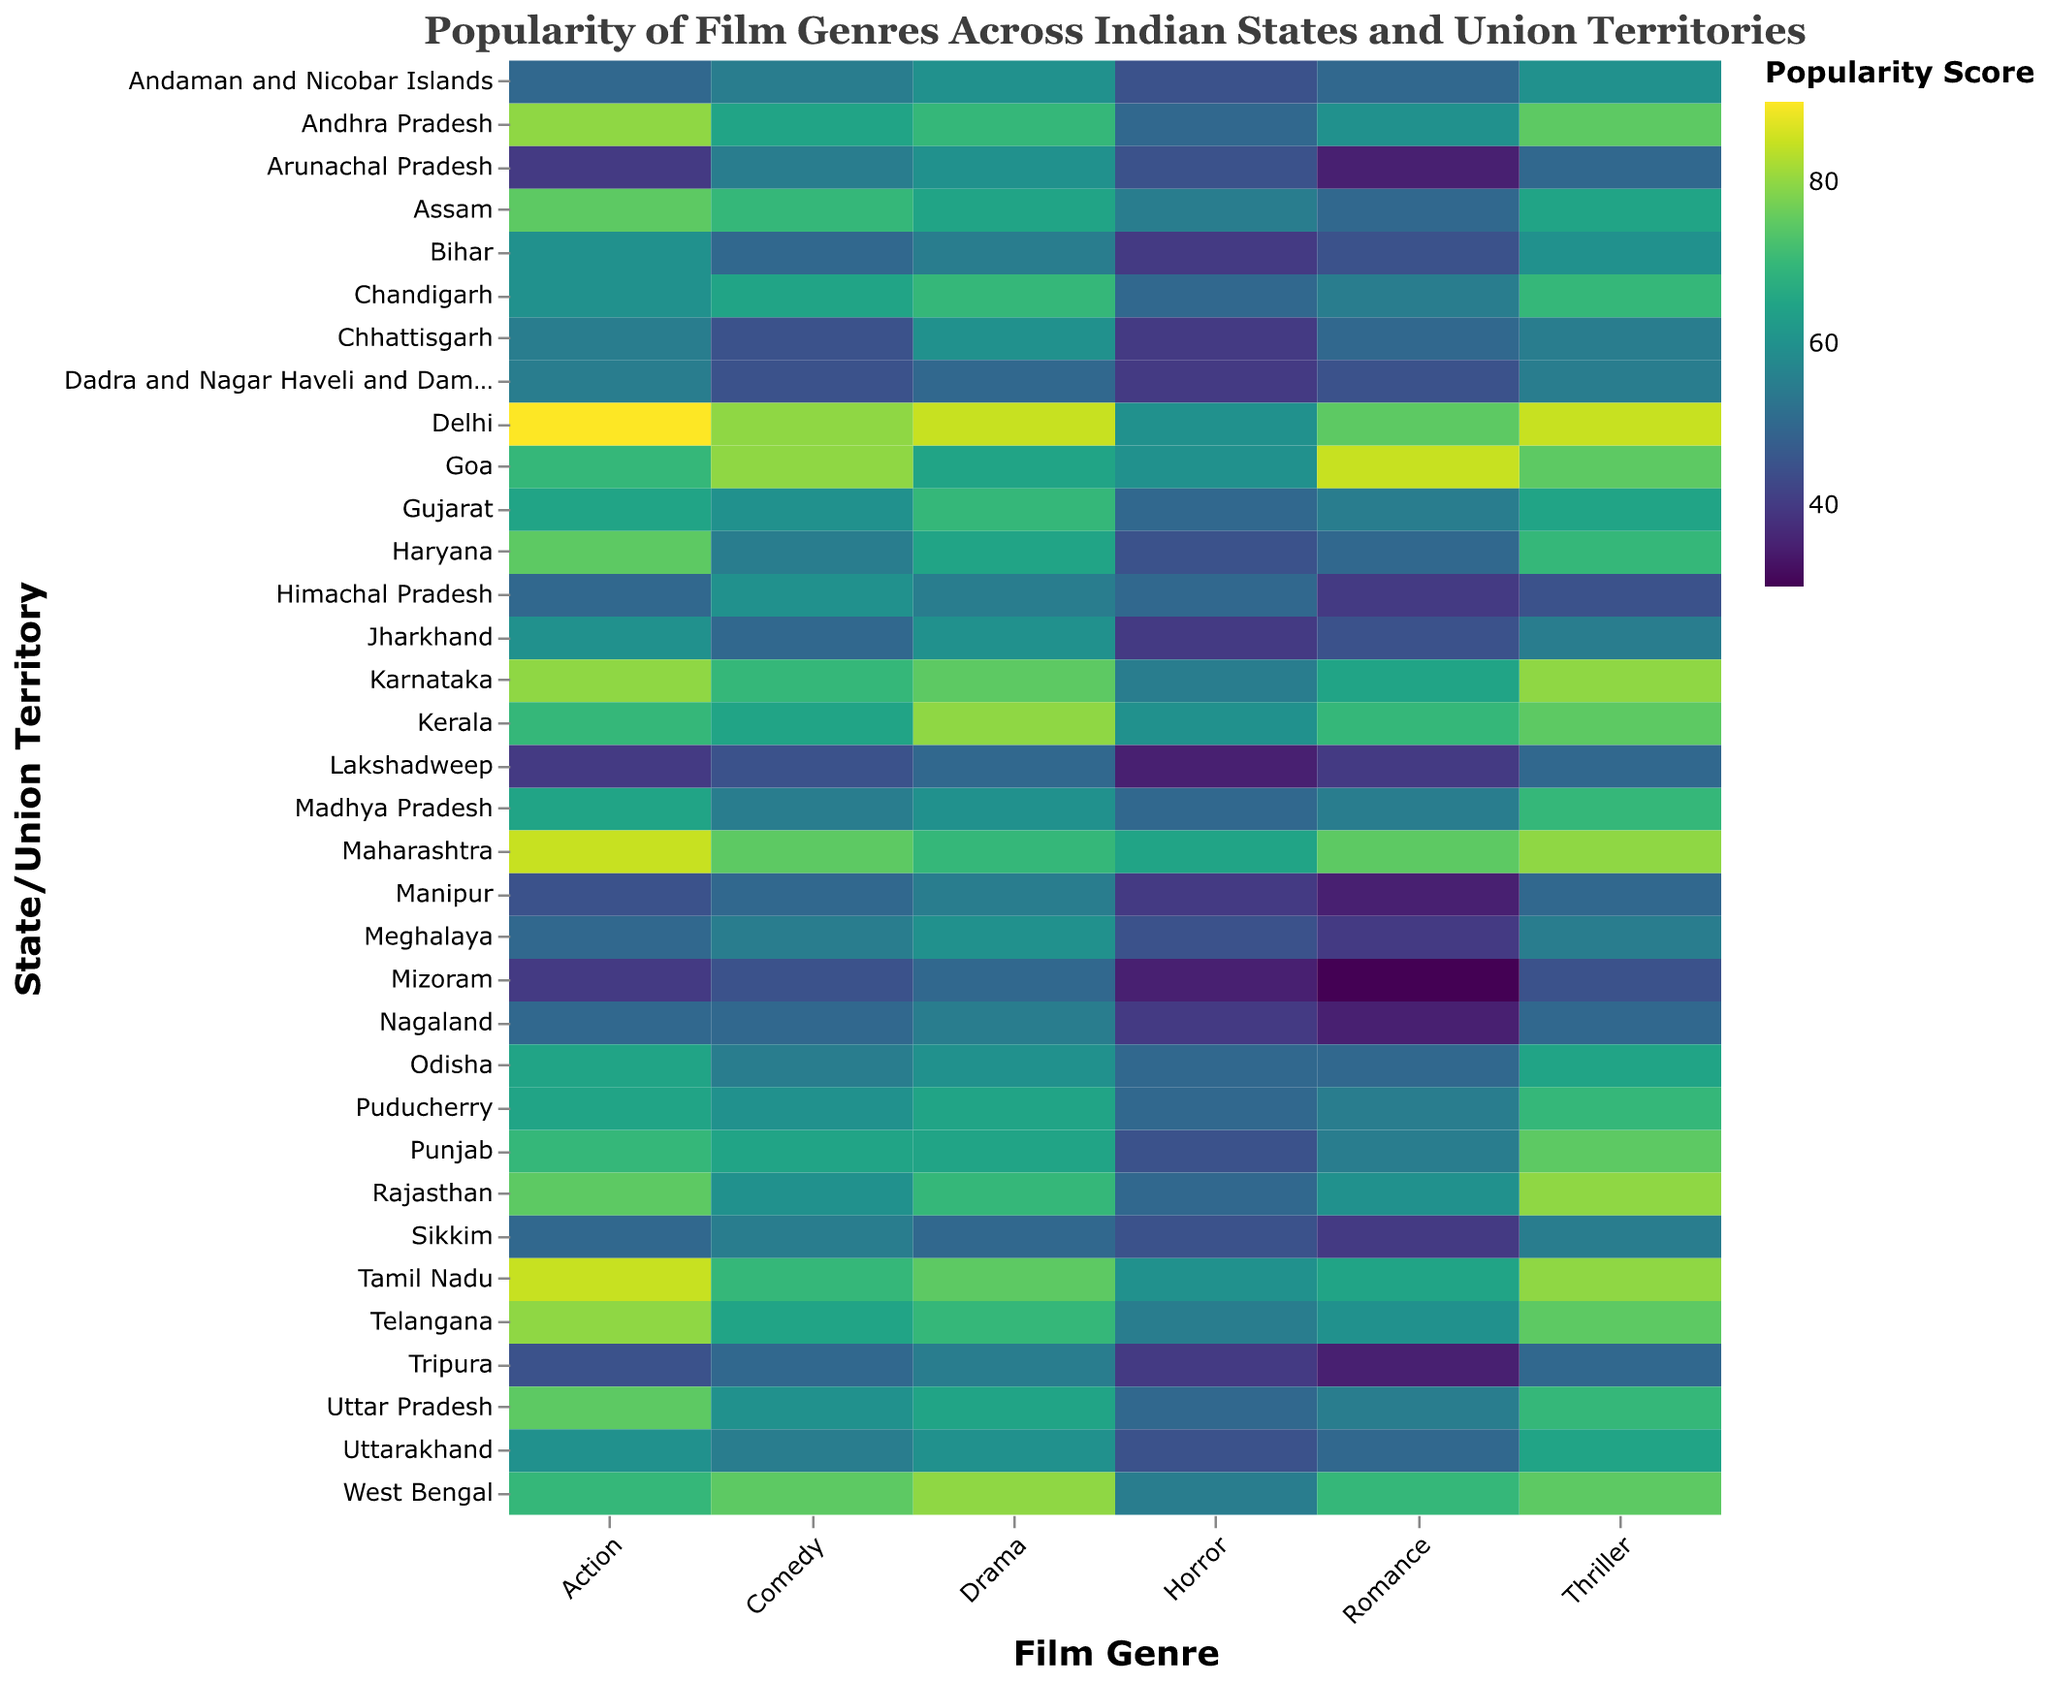What is the title of the heatmap? The title is usually located at the top of the heatmap. By referring to the top, you can find the title which helps in understanding what the heatmap is displaying.
Answer: Popularity of Film Genres Across Indian States and Union Territories Which state shows the highest popularity score for Action movies? By examining the heatmap, look for the cell with the highest value in the "Action" column and check the corresponding state.
Answer: Delhi In which states is Horror the least popular? Check the "Horror" column for the minimum values and cross-reference these with the states. The lowest scores are often highlighted with a color denoting low values.
Answer: Mizoram, Lakshadweep Compare the popularity of Comedy in Goa and Maharashtra. Which state has higher popularity for this genre? Find the cells under the "Comedy" column for Goa and Maharashtra and compare the values. The heatmap color can assist in identifying higher values.
Answer: Goa What is the average popularity score of Romance genre across all states and union territories? Add up all the values in the "Romance" column and divide by the total number of states and union territories. (60+35+50+45+50+85+55+50+40+45+65+70+55+75+35+40+30+35+50+55+60+40+65+60+35+55+50+70+50+55+45+75+40+55 = 1695, 1695/36)
Answer: 47.08 Which state has the most balanced popularity scores across all genres? Look for a state where the color shades for each genre don’t vary much from each other, indicating a similar popularity level across genres.
Answer: Gujarat Is there any state where the popularity of all genres is 60 or above? Check each column for states where all the values are 60 or higher. Each genre for the state must meet or exceed the score of 60.
Answer: Maharashtra Compare the popularity of Drama in Karnataka and Tamil Nadu. Which state has a higher score for Drama? Locate the Drama cells for Karnataka and Tamil Nadu and compare the values.
Answer: Tamil Nadu What is the most popular film genre in West Bengal? In the row for West Bengal, find the cell with the highest value and identify the genre.
Answer: Drama How many states have a maximum popularity score of 85 for any genre? Scan the heatmap for cells with the value 85 and count the number of different states/union territories associated with these cells.
Answer: 5 